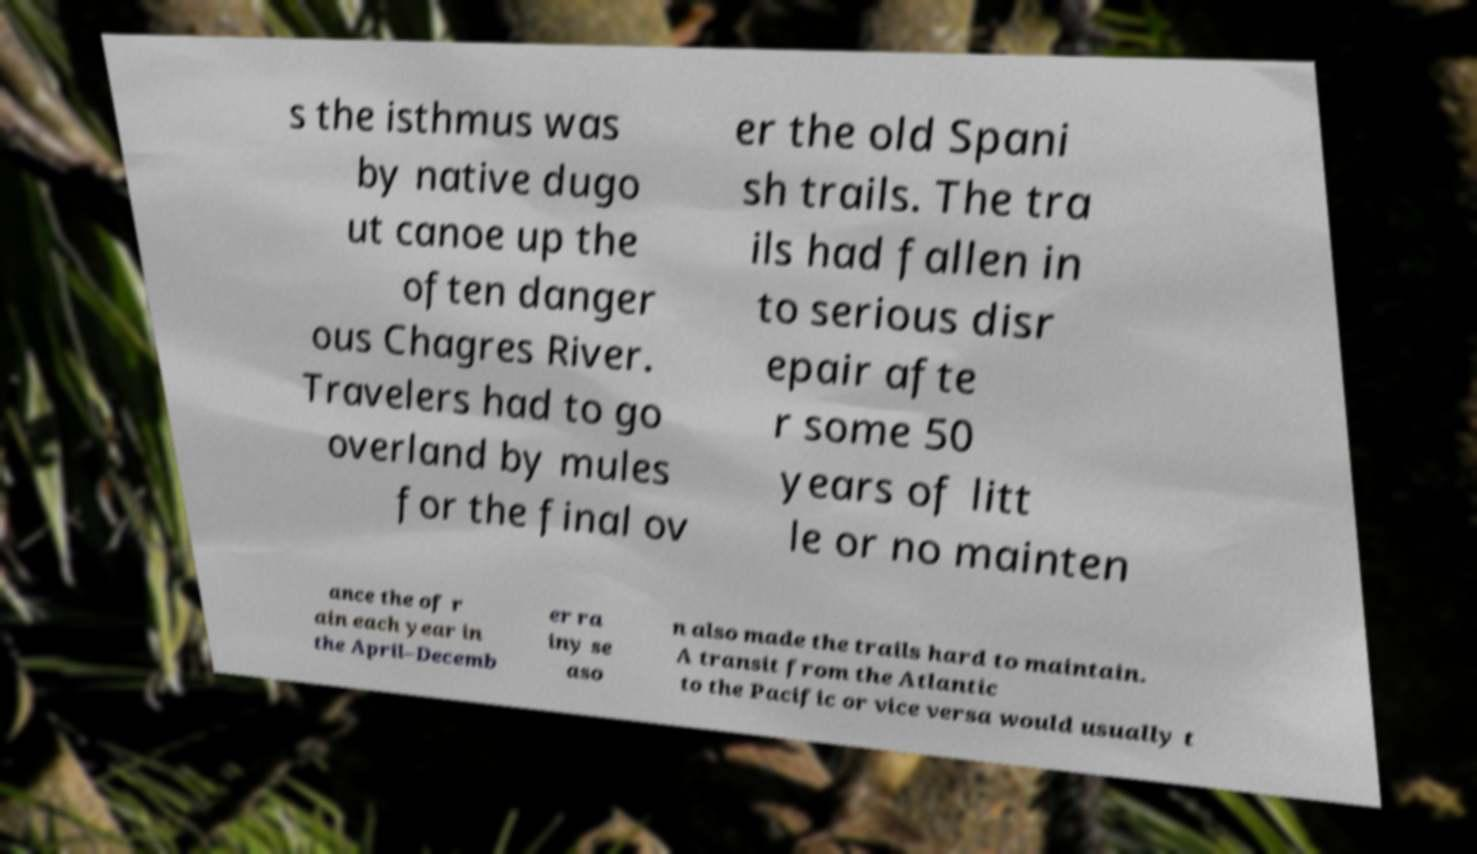Please identify and transcribe the text found in this image. s the isthmus was by native dugo ut canoe up the often danger ous Chagres River. Travelers had to go overland by mules for the final ov er the old Spani sh trails. The tra ils had fallen in to serious disr epair afte r some 50 years of litt le or no mainten ance the of r ain each year in the April–Decemb er ra iny se aso n also made the trails hard to maintain. A transit from the Atlantic to the Pacific or vice versa would usually t 